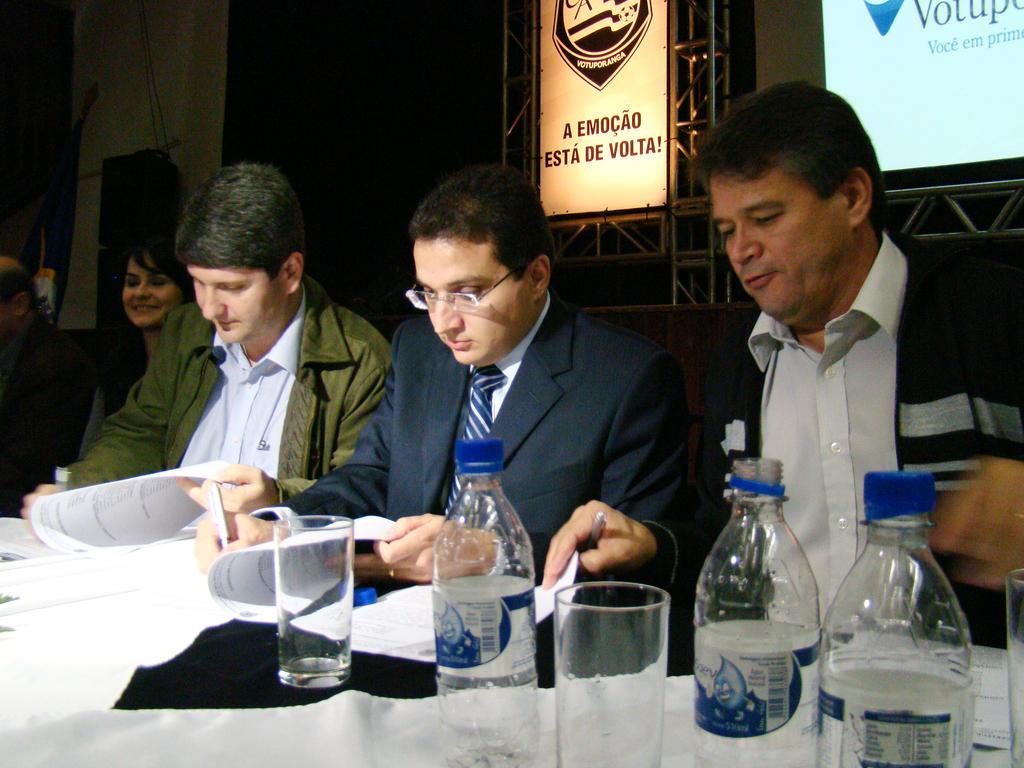Can you describe this image briefly? There are three men sitting. The men in the right side is wearing a black jacket and a white shirt. The man in the middle is wearing a blue jacket. And the man in the left side is wearing a white shirt. They are writing something on the paper. In front of them there is a table. On the table there are some papers, glass and water bottles. Into the left side there is a lady sitting and smiling. At the back of them there are posters and screens. 